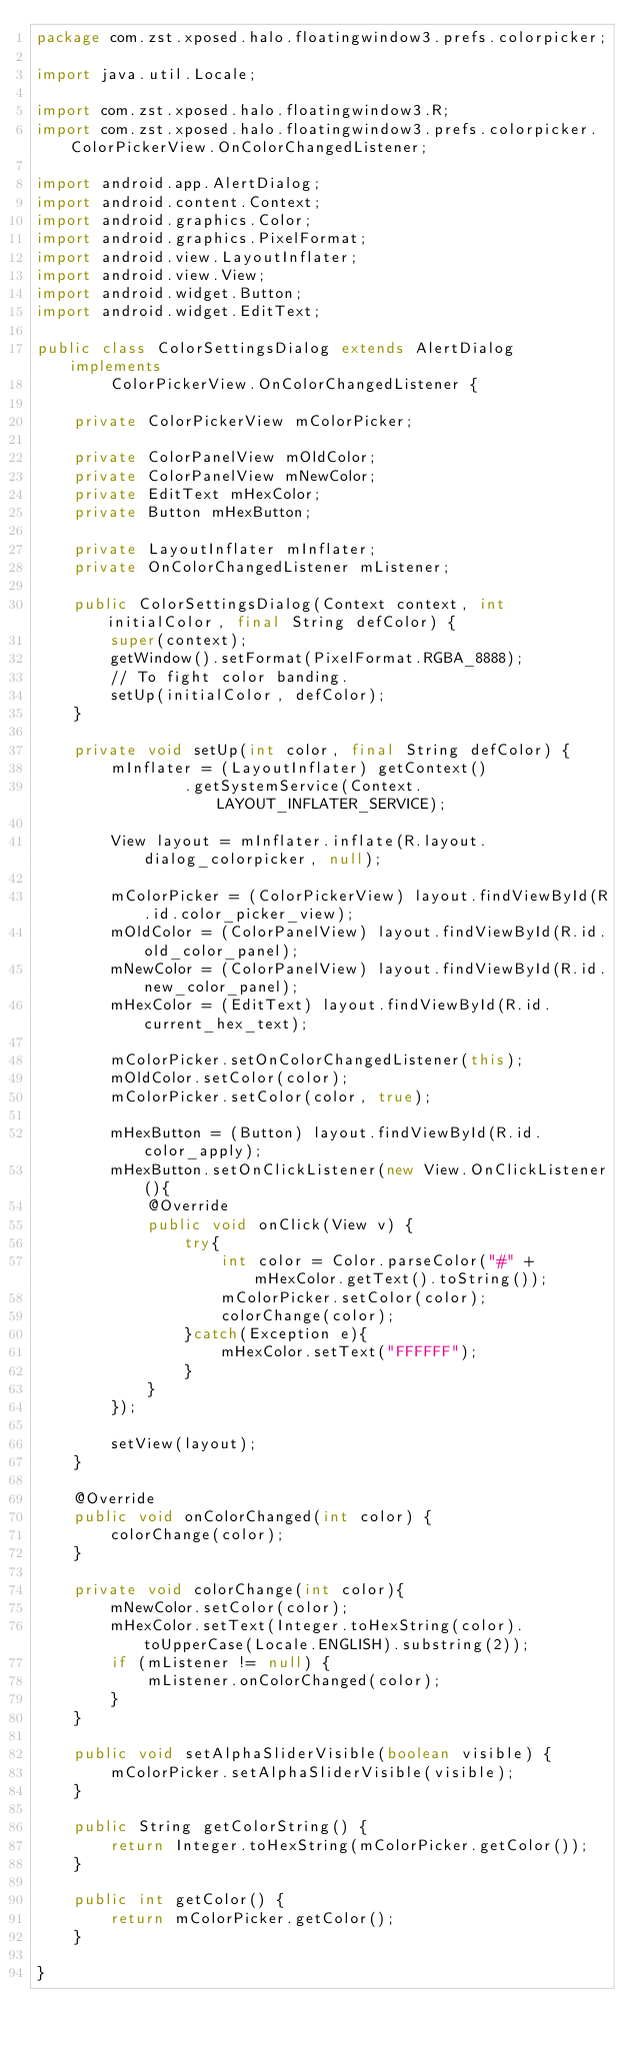<code> <loc_0><loc_0><loc_500><loc_500><_Java_>package com.zst.xposed.halo.floatingwindow3.prefs.colorpicker;

import java.util.Locale;

import com.zst.xposed.halo.floatingwindow3.R;
import com.zst.xposed.halo.floatingwindow3.prefs.colorpicker.ColorPickerView.OnColorChangedListener;

import android.app.AlertDialog;
import android.content.Context;
import android.graphics.Color;
import android.graphics.PixelFormat;
import android.view.LayoutInflater;
import android.view.View;
import android.widget.Button;
import android.widget.EditText;

public class ColorSettingsDialog extends AlertDialog implements
		ColorPickerView.OnColorChangedListener {

	private ColorPickerView mColorPicker;

	private ColorPanelView mOldColor;
	private ColorPanelView mNewColor;
	private EditText mHexColor;
	private Button mHexButton;

	private LayoutInflater mInflater;
	private OnColorChangedListener mListener;

	public ColorSettingsDialog(Context context, int initialColor, final String defColor) {
		super(context);
		getWindow().setFormat(PixelFormat.RGBA_8888);
		// To fight color banding.
		setUp(initialColor, defColor);
	}

	private void setUp(int color, final String defColor) {
        mInflater = (LayoutInflater) getContext()
                .getSystemService(Context.LAYOUT_INFLATER_SERVICE);

        View layout = mInflater.inflate(R.layout.dialog_colorpicker, null);

        mColorPicker = (ColorPickerView) layout.findViewById(R.id.color_picker_view);
        mOldColor = (ColorPanelView) layout.findViewById(R.id.old_color_panel);
        mNewColor = (ColorPanelView) layout.findViewById(R.id.new_color_panel);
        mHexColor = (EditText) layout.findViewById(R.id.current_hex_text);

        mColorPicker.setOnColorChangedListener(this);
        mOldColor.setColor(color);
        mColorPicker.setColor(color, true);

        mHexButton = (Button) layout.findViewById(R.id.color_apply);
        mHexButton.setOnClickListener(new View.OnClickListener(){
        	@Override
        	public void onClick(View v) {
        		try{
        			int color = Color.parseColor("#" + mHexColor.getText().toString());
        			mColorPicker.setColor(color);
        			colorChange(color);
        		}catch(Exception e){
        			mHexColor.setText("FFFFFF");
        		}
        	}
        });

        setView(layout);
    }

	@Override
	public void onColorChanged(int color) {
		colorChange(color);
	}

	private void colorChange(int color){
		mNewColor.setColor(color);
		mHexColor.setText(Integer.toHexString(color).toUpperCase(Locale.ENGLISH).substring(2));
		if (mListener != null) {
			mListener.onColorChanged(color);
		}
	}

	public void setAlphaSliderVisible(boolean visible) {
		mColorPicker.setAlphaSliderVisible(visible);
	}

	public String getColorString() {
		return Integer.toHexString(mColorPicker.getColor());
	}

	public int getColor() {
		return mColorPicker.getColor();
	}

}
</code> 